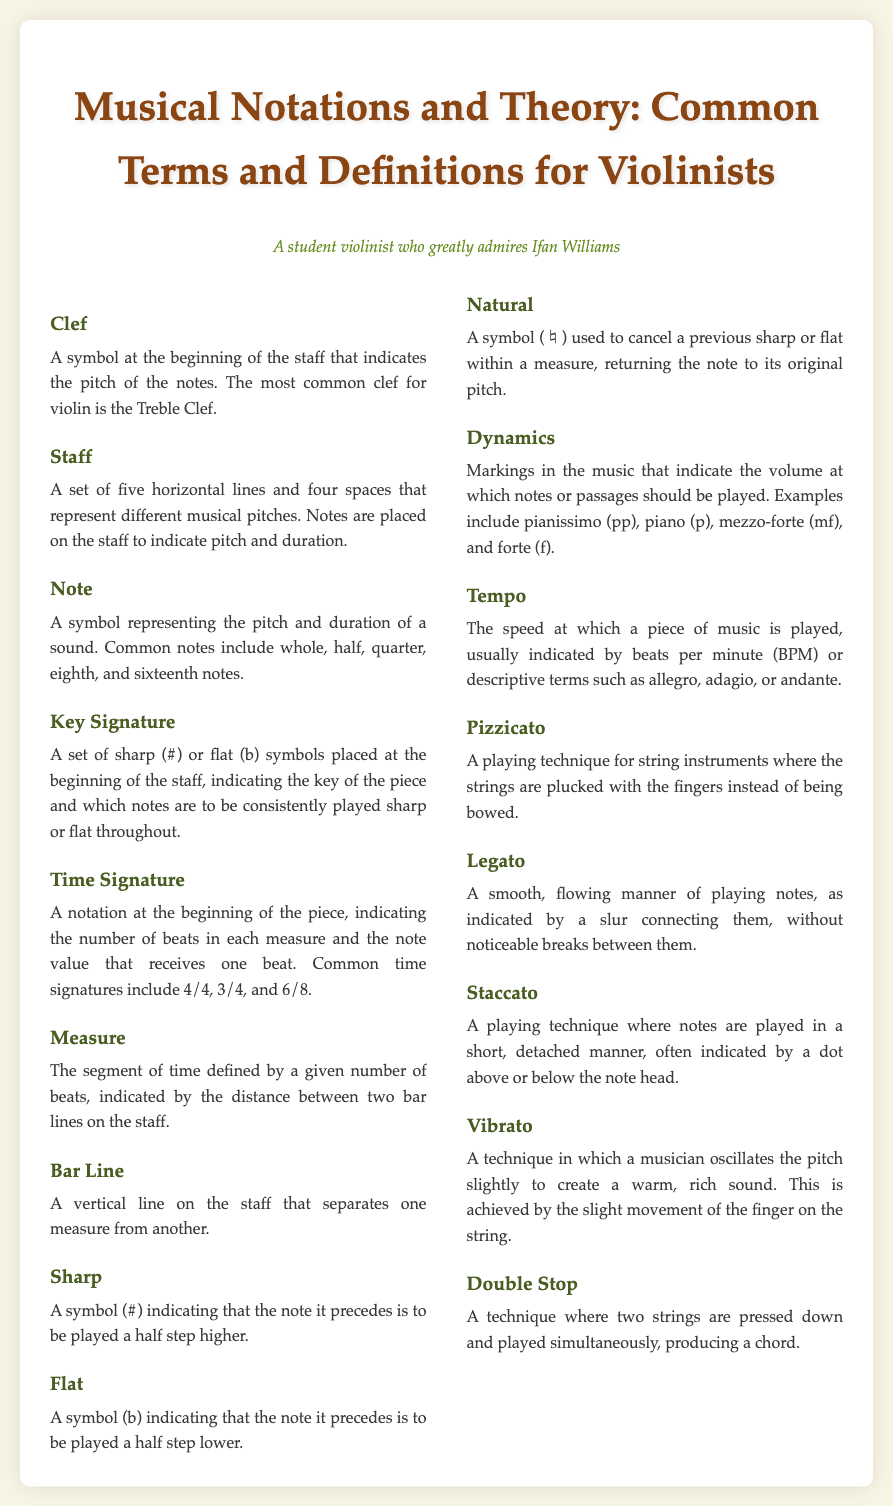What is the most common clef for violin? The document states that the most common clef for violin is the Treble Clef.
Answer: Treble Clef What does a Key Signature indicate? The Key Signature indicates the key of the piece and which notes are to be consistently played sharp or flat throughout.
Answer: Key of the piece What is the purpose of a Time Signature? The Time Signature indicates the number of beats in each measure and the note value that receives one beat.
Answer: Number of beats What symbol indicates a note is played a half step higher? The symbol (#) is used to indicate that the note is to be played a half step higher.
Answer: Sharp What is the technique called where two strings are played simultaneously? The technique where two strings are pressed down and played simultaneously is called Double Stop.
Answer: Double Stop What is indicated by a slur connecting notes? A slur connecting notes indicates that they should be played in a smooth, flowing manner, without noticeable breaks.
Answer: Legato What does the term 'pianissimo' mean? The term 'pianissimo' refers to a dynamic marking indicating very soft volume.
Answer: Very soft volume How are notes played in a staccato manner? Notes played in a staccato manner are done so in a short, detached way.
Answer: Short, detached What does 'vibrato' involve? Vibrato involves oscillating the pitch slightly to create a warm, rich sound.
Answer: Oscillating pitch 